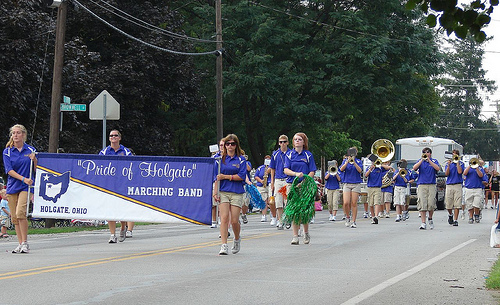<image>
Is there a man next to the women? No. The man is not positioned next to the women. They are located in different areas of the scene. Is there a woman one in front of the man two? Yes. The woman one is positioned in front of the man two, appearing closer to the camera viewpoint. 